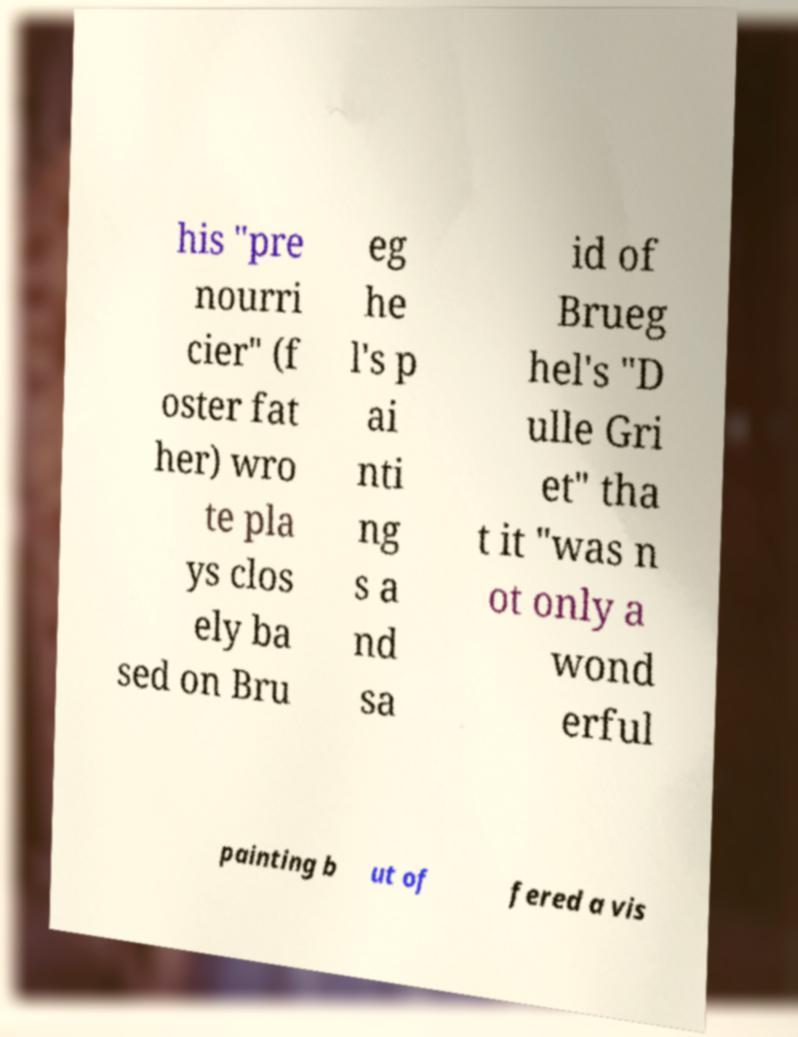For documentation purposes, I need the text within this image transcribed. Could you provide that? his "pre nourri cier" (f oster fat her) wro te pla ys clos ely ba sed on Bru eg he l's p ai nti ng s a nd sa id of Brueg hel's "D ulle Gri et" tha t it "was n ot only a wond erful painting b ut of fered a vis 